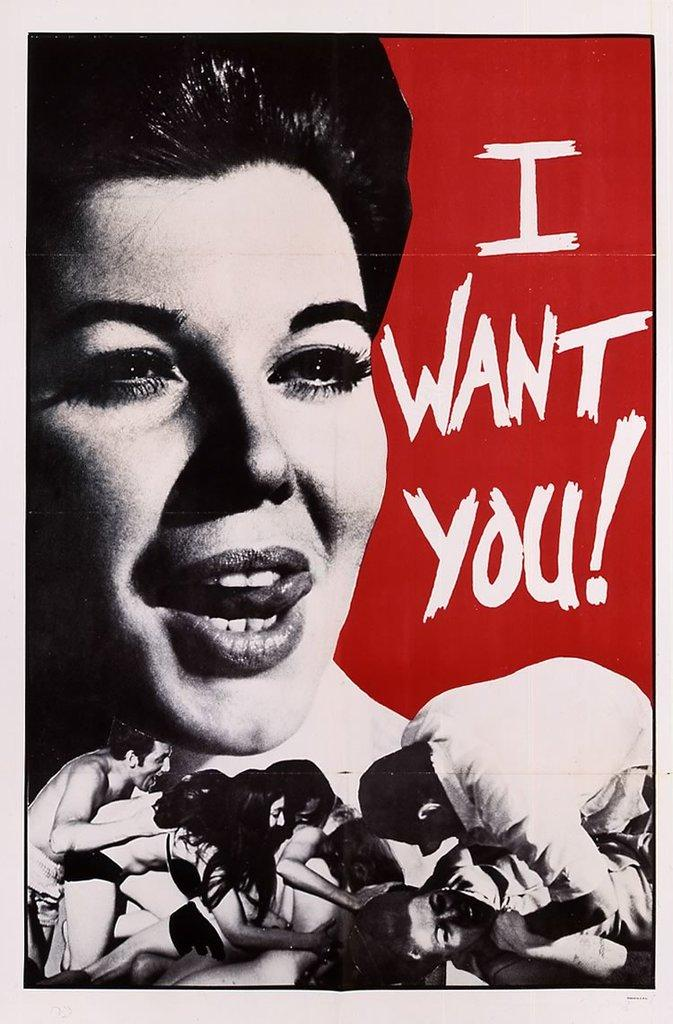<image>
Relay a brief, clear account of the picture shown. The poster screams I want you with an exclamation point 